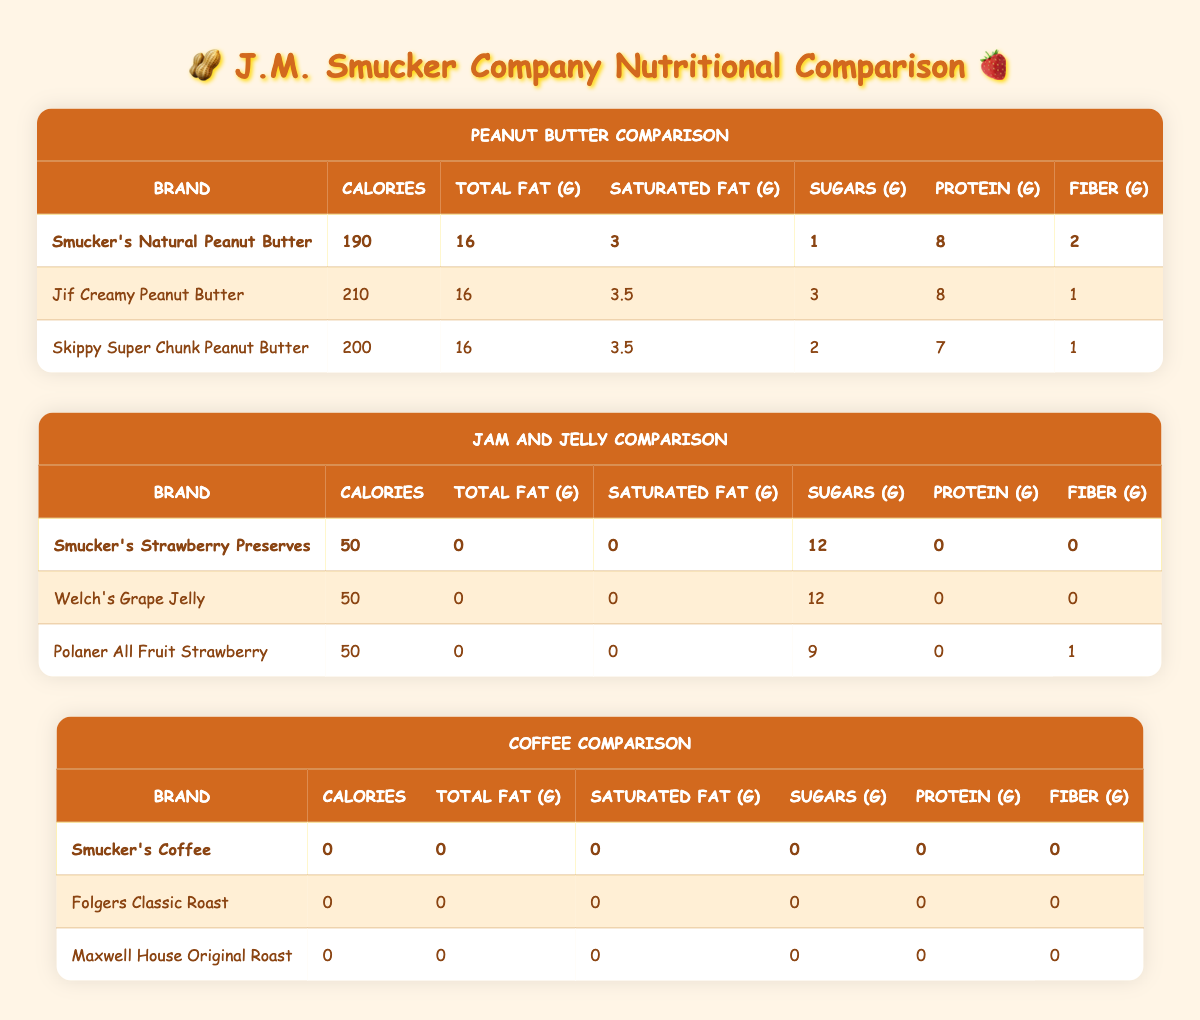What is the calorie content of Smucker's Natural Peanut Butter? According to the table, Smucker's Natural Peanut Butter has a calorie content of 190.
Answer: 190 Which brand of peanut butter has the highest sugar content? In the table, Jif Creamy Peanut Butter has the highest sugar content at 3 grams, while Smucker's has 1 gram and Skippy has 2 grams. Comparing these values shows Jif has the highest sugar content.
Answer: Jif Creamy Peanut Butter Is there any peanut butter brand that has zero sugars? By reviewing the sugar content column, we see that all brands, including Smucker's, Jif, and Skippy, have some amount of sugar, with Smucker's having the least at 1 gram. Thus, there are no brands with zero sugars.
Answer: No How much total fat is in Smucker's Strawberry Preserves? In the row for Smucker's Strawberry Preserves, the total fat content is listed as 0 grams.
Answer: 0 What is the difference in protein content between Skippy Super Chunk and Smucker's Natural Peanut Butter? Looking at the protein content, Skippy has 7 grams and Smucker's has 8 grams. The difference is calculated as 8 - 7 = 1 gram.
Answer: 1 gram Which brand has the highest fiber content among the peanut butters? Examining the fiber content of the brands, Smucker's Natural Peanut Butter has 2 grams, while both Jif and Skippy have 1 gram. Hence, Smucker's has the highest fiber among the three.
Answer: Smucker's Natural Peanut Butter How many total calories would you consume if you had one serving of each peanut butter? Adding the calorie contents: 190 (Smucker's) + 210 (Jif) + 200 (Skippy) gives a total of 600 calories for one serving of each peanut butter.
Answer: 600 calories Is Smucker's Coffee different in calories compared to Folgers Classic Roast? Both Smucker's Coffee and Folgers Classic Roast have zero calories as indicated in the table. Therefore, they are the same in this regard.
Answer: No How many grams of sugars do Smucker’s Strawberry Preserves have in comparison to Polaner All Fruit Strawberry? Smucker's Strawberry Preserves have 12 grams of sugars, while Polaner All Fruit Strawberry has 9 grams. The comparison shows that Smucker's contains 3 grams more sugar than Polaner.
Answer: 3 grams more 